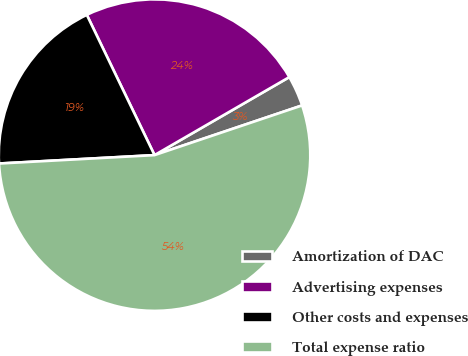<chart> <loc_0><loc_0><loc_500><loc_500><pie_chart><fcel>Amortization of DAC<fcel>Advertising expenses<fcel>Other costs and expenses<fcel>Total expense ratio<nl><fcel>3.18%<fcel>23.81%<fcel>18.7%<fcel>54.31%<nl></chart> 